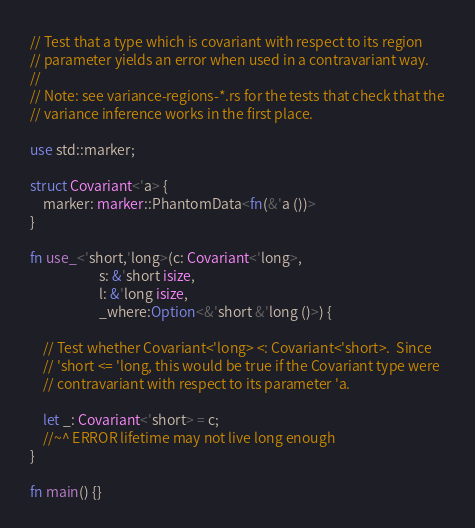<code> <loc_0><loc_0><loc_500><loc_500><_Rust_>// Test that a type which is covariant with respect to its region
// parameter yields an error when used in a contravariant way.
//
// Note: see variance-regions-*.rs for the tests that check that the
// variance inference works in the first place.

use std::marker;

struct Covariant<'a> {
    marker: marker::PhantomData<fn(&'a ())>
}

fn use_<'short,'long>(c: Covariant<'long>,
                      s: &'short isize,
                      l: &'long isize,
                      _where:Option<&'short &'long ()>) {

    // Test whether Covariant<'long> <: Covariant<'short>.  Since
    // 'short <= 'long, this would be true if the Covariant type were
    // contravariant with respect to its parameter 'a.

    let _: Covariant<'short> = c;
    //~^ ERROR lifetime may not live long enough
}

fn main() {}
</code> 